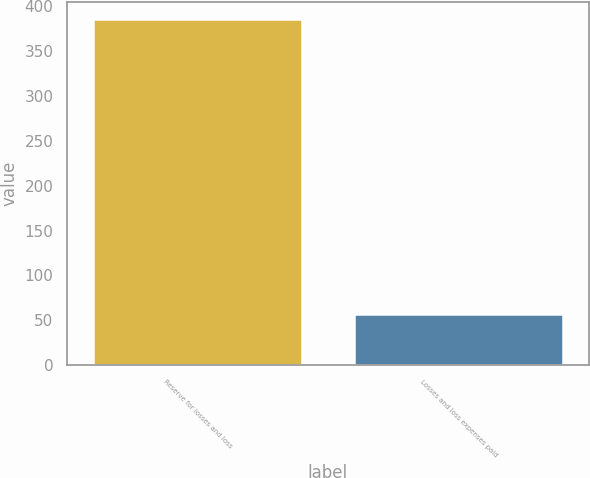Convert chart. <chart><loc_0><loc_0><loc_500><loc_500><bar_chart><fcel>Reserve for losses and loss<fcel>Losses and loss expenses paid<nl><fcel>386<fcel>57<nl></chart> 